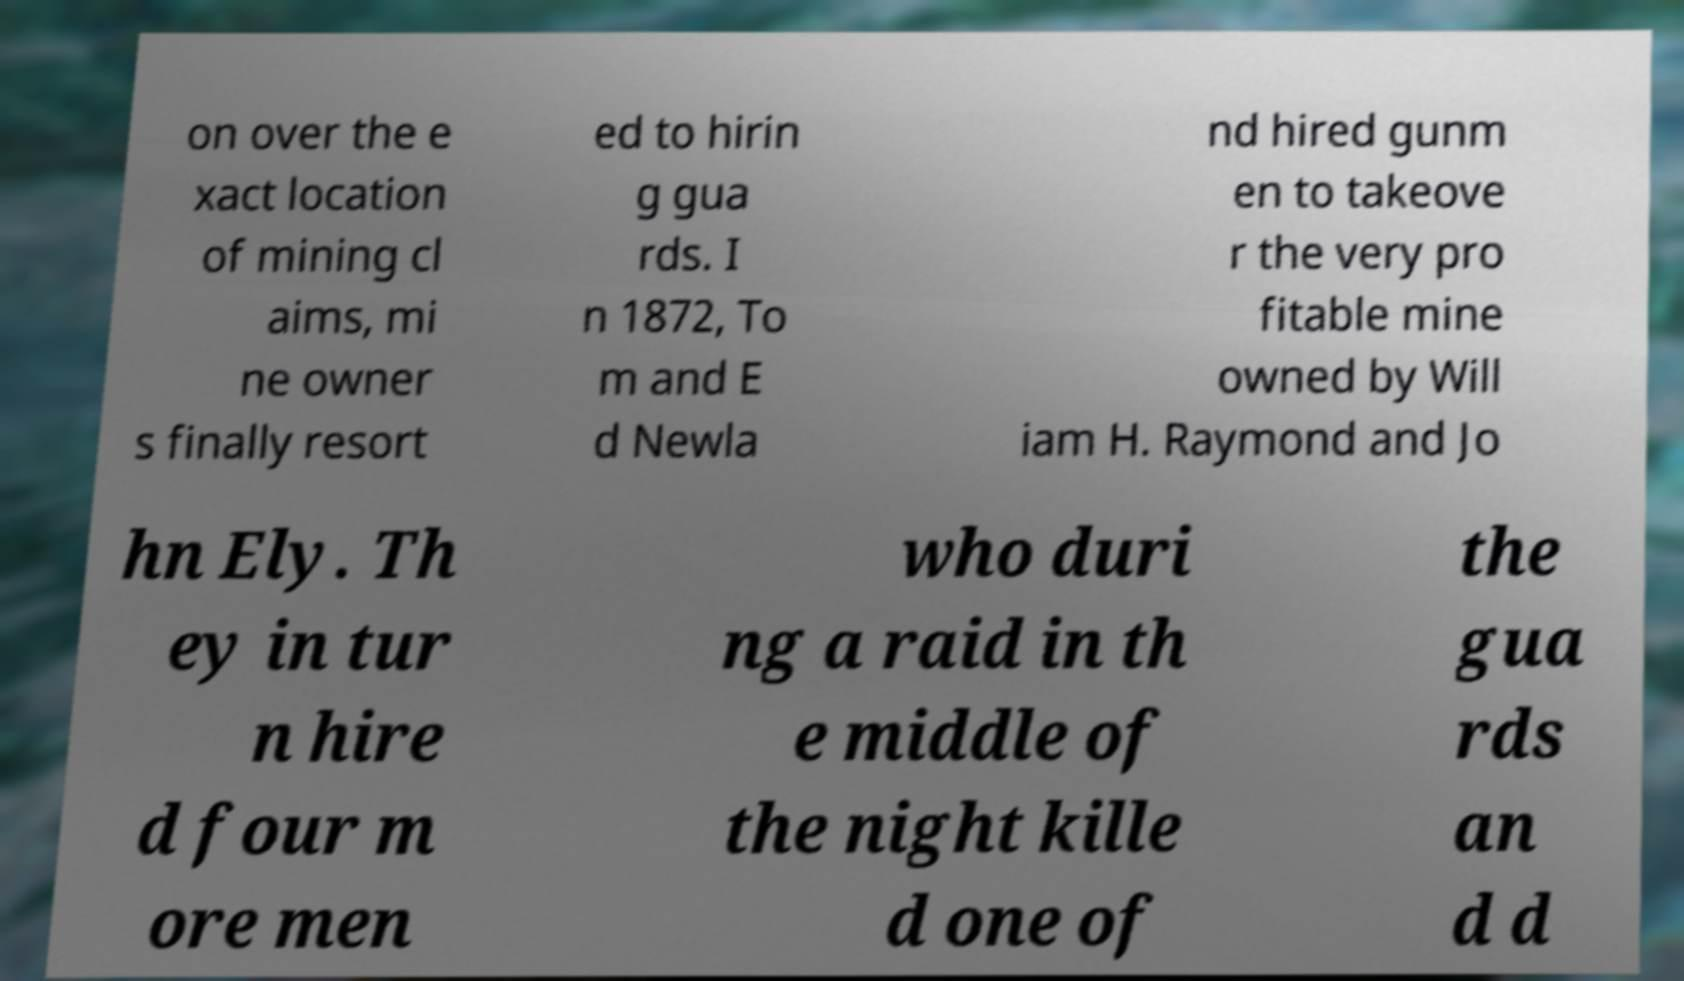What messages or text are displayed in this image? I need them in a readable, typed format. on over the e xact location of mining cl aims, mi ne owner s finally resort ed to hirin g gua rds. I n 1872, To m and E d Newla nd hired gunm en to takeove r the very pro fitable mine owned by Will iam H. Raymond and Jo hn Ely. Th ey in tur n hire d four m ore men who duri ng a raid in th e middle of the night kille d one of the gua rds an d d 